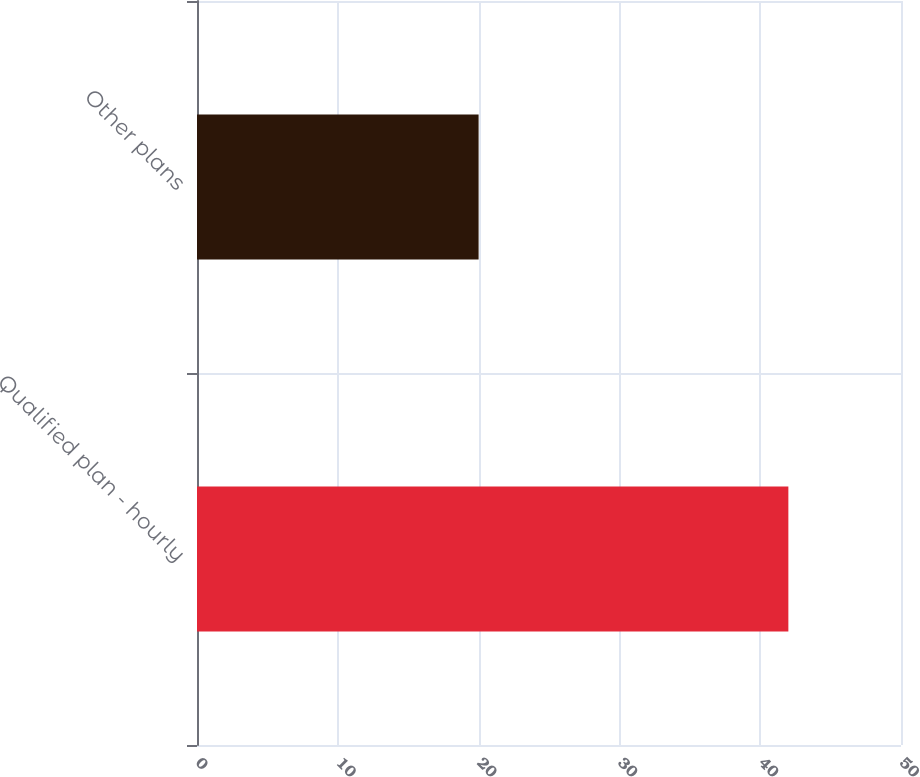<chart> <loc_0><loc_0><loc_500><loc_500><bar_chart><fcel>Qualified plan - hourly<fcel>Other plans<nl><fcel>42<fcel>20<nl></chart> 